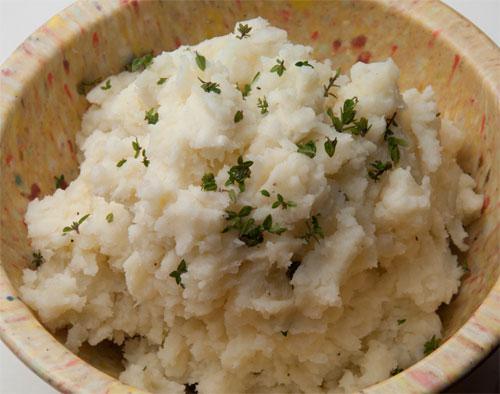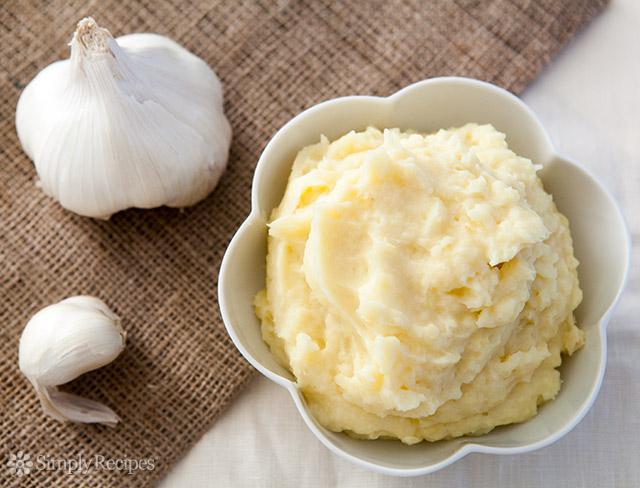The first image is the image on the left, the second image is the image on the right. Examine the images to the left and right. Is the description "One image shows food in a white bowl, and the other does not." accurate? Answer yes or no. Yes. The first image is the image on the left, the second image is the image on the right. Examine the images to the left and right. Is the description "Large flakes of green garnish adorn the potatoes in the image on left." accurate? Answer yes or no. Yes. 